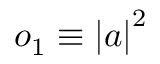Convert formula to latex. <formula><loc_0><loc_0><loc_500><loc_500>o _ { 1 } \equiv \left | a \right | ^ { 2 }</formula> 